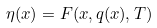Convert formula to latex. <formula><loc_0><loc_0><loc_500><loc_500>\eta ( x ) = F ( x , q ( x ) , T )</formula> 